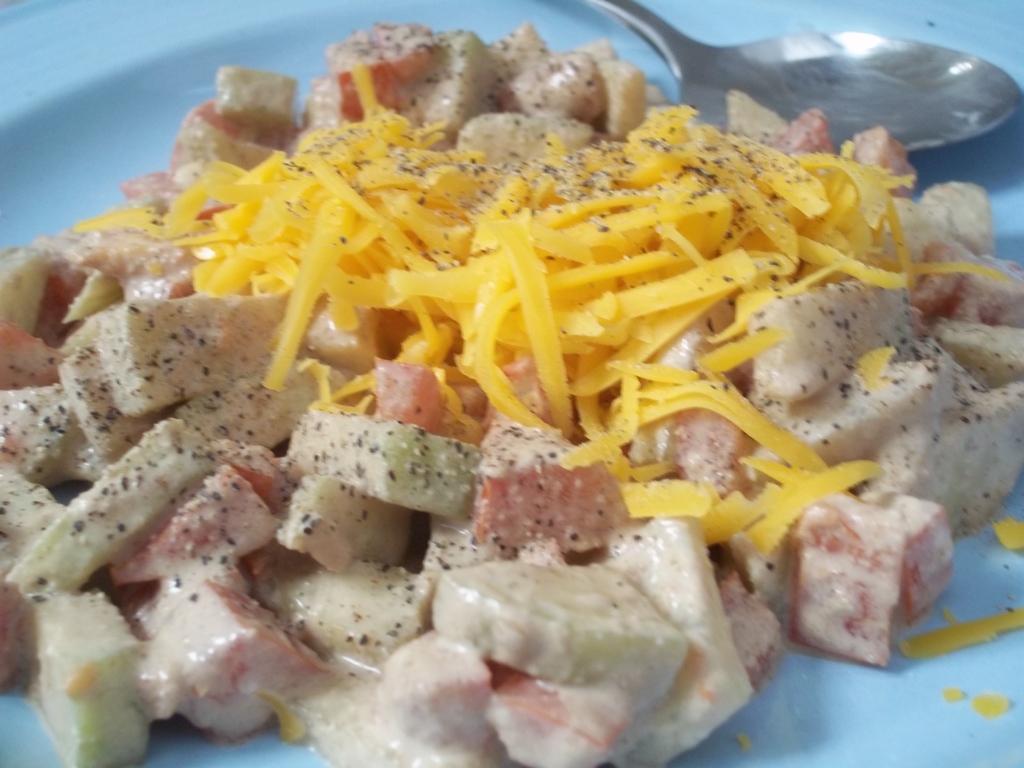Describe this image in one or two sentences. In the image we can see a plate, white in color, in the plate we can see the food item and a spoon. 